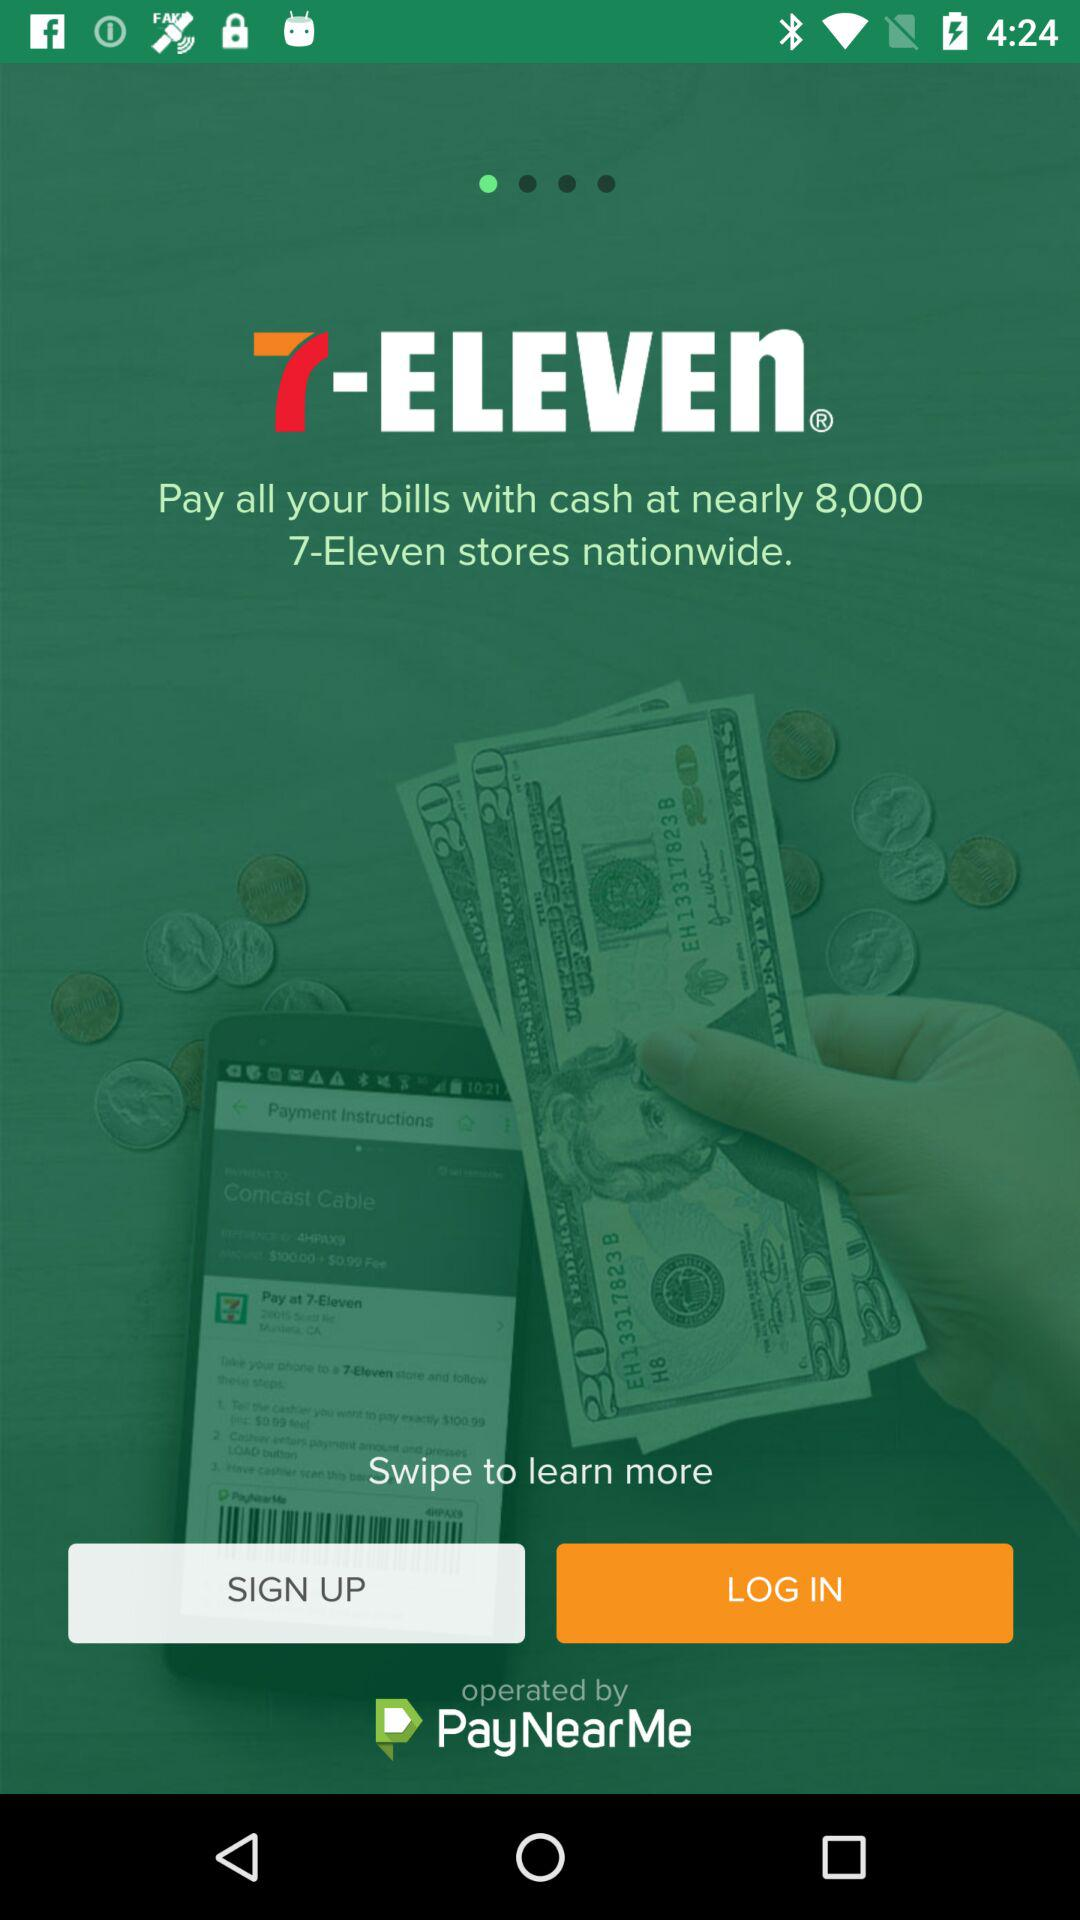At how many stores can we pay our bills with cash? You can pay your bills with cash at nearly 8,000 stores. 